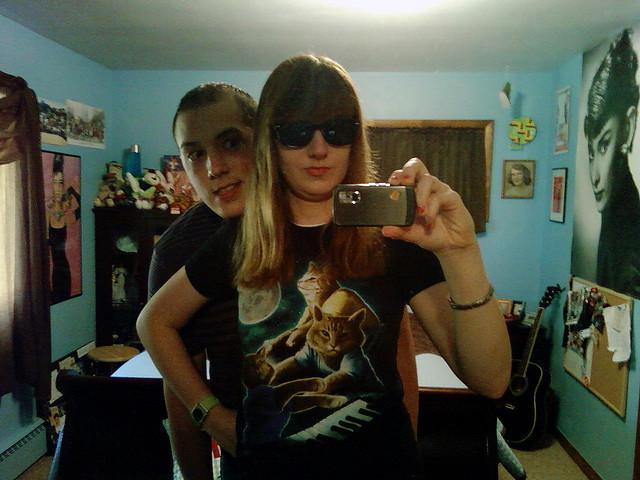How many people are in the picture?
Give a very brief answer. 2. How many people are in the room?
Give a very brief answer. 2. How many pairs of sunglasses are there?
Give a very brief answer. 1. How many people are recording or taking pictures of the man?
Give a very brief answer. 1. How many chairs are in the picture?
Give a very brief answer. 1. How many people can be seen?
Give a very brief answer. 3. How many towers have clocks on them?
Give a very brief answer. 0. 